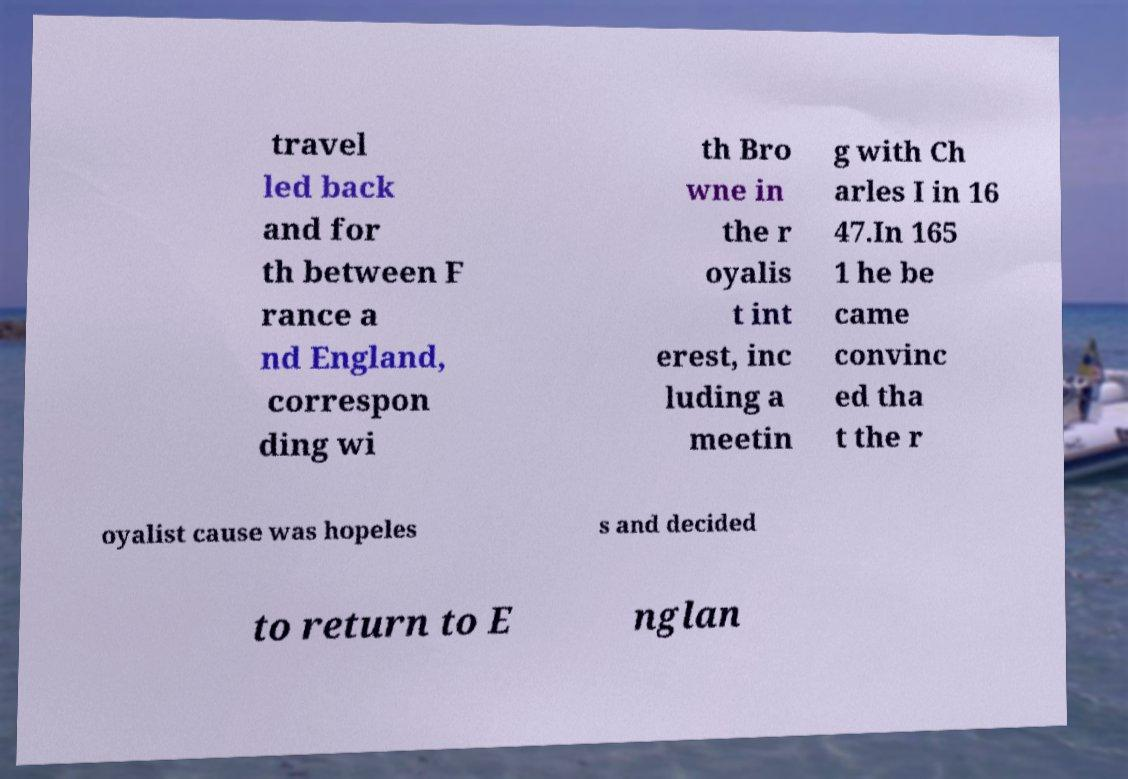Could you extract and type out the text from this image? travel led back and for th between F rance a nd England, correspon ding wi th Bro wne in the r oyalis t int erest, inc luding a meetin g with Ch arles I in 16 47.In 165 1 he be came convinc ed tha t the r oyalist cause was hopeles s and decided to return to E nglan 